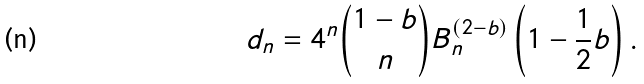Convert formula to latex. <formula><loc_0><loc_0><loc_500><loc_500>d _ { n } = 4 ^ { n } \binom { 1 - b } { n } B _ { n } ^ { ( 2 - b ) } \left ( 1 - \frac { 1 } { 2 } b \right ) .</formula> 